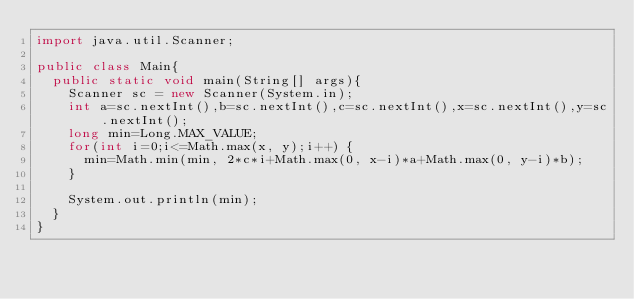<code> <loc_0><loc_0><loc_500><loc_500><_Java_>import java.util.Scanner;

public class Main{
  public static void main(String[] args){
	  Scanner sc = new Scanner(System.in);
	  int a=sc.nextInt(),b=sc.nextInt(),c=sc.nextInt(),x=sc.nextInt(),y=sc.nextInt();
	  long min=Long.MAX_VALUE;
	  for(int i=0;i<=Math.max(x, y);i++) {
		  min=Math.min(min, 2*c*i+Math.max(0, x-i)*a+Math.max(0, y-i)*b);
	  }

	  System.out.println(min);
  }
}
</code> 